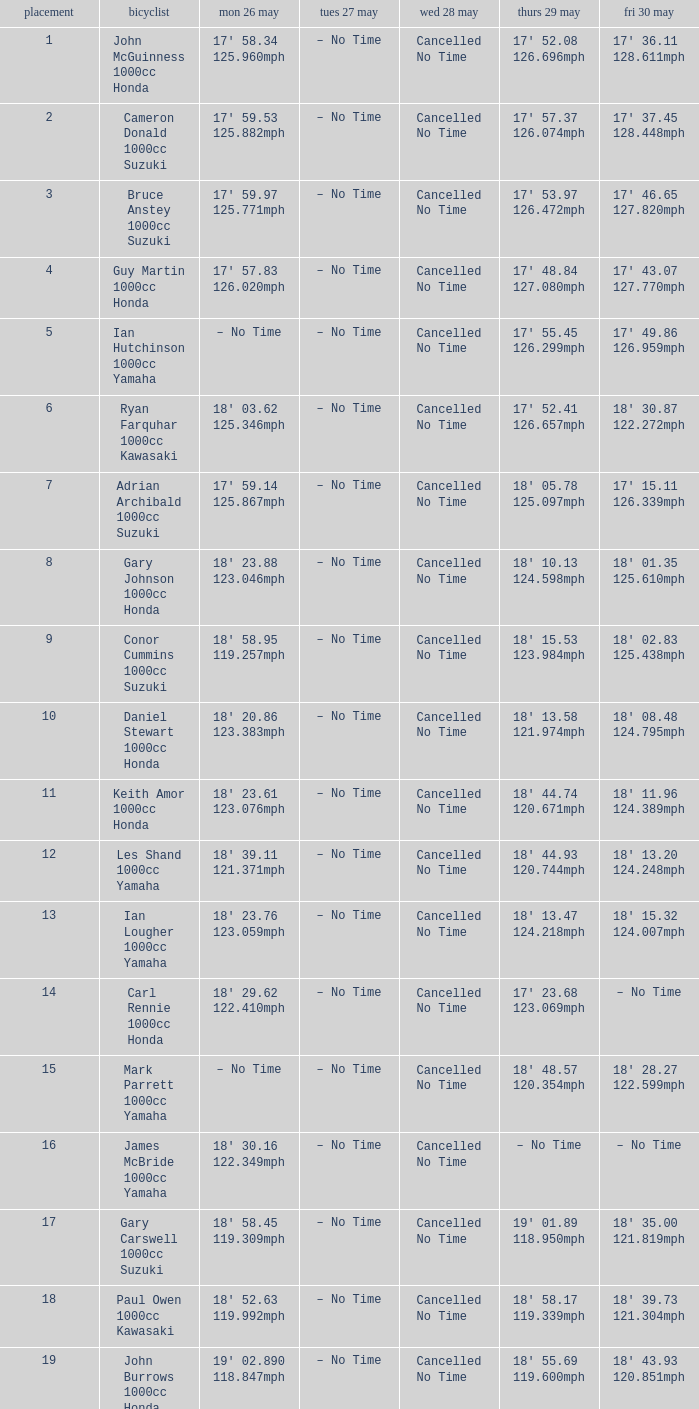What tims is wed may 28 and mon may 26 is 17' 58.34 125.960mph? Cancelled No Time. Parse the full table. {'header': ['placement', 'bicyclist', 'mon 26 may', 'tues 27 may', 'wed 28 may', 'thurs 29 may', 'fri 30 may'], 'rows': [['1', 'John McGuinness 1000cc Honda', "17' 58.34 125.960mph", '– No Time', 'Cancelled No Time', "17' 52.08 126.696mph", "17' 36.11 128.611mph"], ['2', 'Cameron Donald 1000cc Suzuki', "17' 59.53 125.882mph", '– No Time', 'Cancelled No Time', "17' 57.37 126.074mph", "17' 37.45 128.448mph"], ['3', 'Bruce Anstey 1000cc Suzuki', "17' 59.97 125.771mph", '– No Time', 'Cancelled No Time', "17' 53.97 126.472mph", "17' 46.65 127.820mph"], ['4', 'Guy Martin 1000cc Honda', "17' 57.83 126.020mph", '– No Time', 'Cancelled No Time', "17' 48.84 127.080mph", "17' 43.07 127.770mph"], ['5', 'Ian Hutchinson 1000cc Yamaha', '– No Time', '– No Time', 'Cancelled No Time', "17' 55.45 126.299mph", "17' 49.86 126.959mph"], ['6', 'Ryan Farquhar 1000cc Kawasaki', "18' 03.62 125.346mph", '– No Time', 'Cancelled No Time', "17' 52.41 126.657mph", "18' 30.87 122.272mph"], ['7', 'Adrian Archibald 1000cc Suzuki', "17' 59.14 125.867mph", '– No Time', 'Cancelled No Time', "18' 05.78 125.097mph", "17' 15.11 126.339mph"], ['8', 'Gary Johnson 1000cc Honda', "18' 23.88 123.046mph", '– No Time', 'Cancelled No Time', "18' 10.13 124.598mph", "18' 01.35 125.610mph"], ['9', 'Conor Cummins 1000cc Suzuki', "18' 58.95 119.257mph", '– No Time', 'Cancelled No Time', "18' 15.53 123.984mph", "18' 02.83 125.438mph"], ['10', 'Daniel Stewart 1000cc Honda', "18' 20.86 123.383mph", '– No Time', 'Cancelled No Time', "18' 13.58 121.974mph", "18' 08.48 124.795mph"], ['11', 'Keith Amor 1000cc Honda', "18' 23.61 123.076mph", '– No Time', 'Cancelled No Time', "18' 44.74 120.671mph", "18' 11.96 124.389mph"], ['12', 'Les Shand 1000cc Yamaha', "18' 39.11 121.371mph", '– No Time', 'Cancelled No Time', "18' 44.93 120.744mph", "18' 13.20 124.248mph"], ['13', 'Ian Lougher 1000cc Yamaha', "18' 23.76 123.059mph", '– No Time', 'Cancelled No Time', "18' 13.47 124.218mph", "18' 15.32 124.007mph"], ['14', 'Carl Rennie 1000cc Honda', "18' 29.62 122.410mph", '– No Time', 'Cancelled No Time', "17' 23.68 123.069mph", '– No Time'], ['15', 'Mark Parrett 1000cc Yamaha', '– No Time', '– No Time', 'Cancelled No Time', "18' 48.57 120.354mph", "18' 28.27 122.599mph"], ['16', 'James McBride 1000cc Yamaha', "18' 30.16 122.349mph", '– No Time', 'Cancelled No Time', '– No Time', '– No Time'], ['17', 'Gary Carswell 1000cc Suzuki', "18' 58.45 119.309mph", '– No Time', 'Cancelled No Time', "19' 01.89 118.950mph", "18' 35.00 121.819mph"], ['18', 'Paul Owen 1000cc Kawasaki', "18' 52.63 119.992mph", '– No Time', 'Cancelled No Time', "18' 58.17 119.339mph", "18' 39.73 121.304mph"], ['19', 'John Burrows 1000cc Honda', "19' 02.890 118.847mph", '– No Time', 'Cancelled No Time', "18' 55.69 119.600mph", "18' 43.93 120.851mph"]]} 